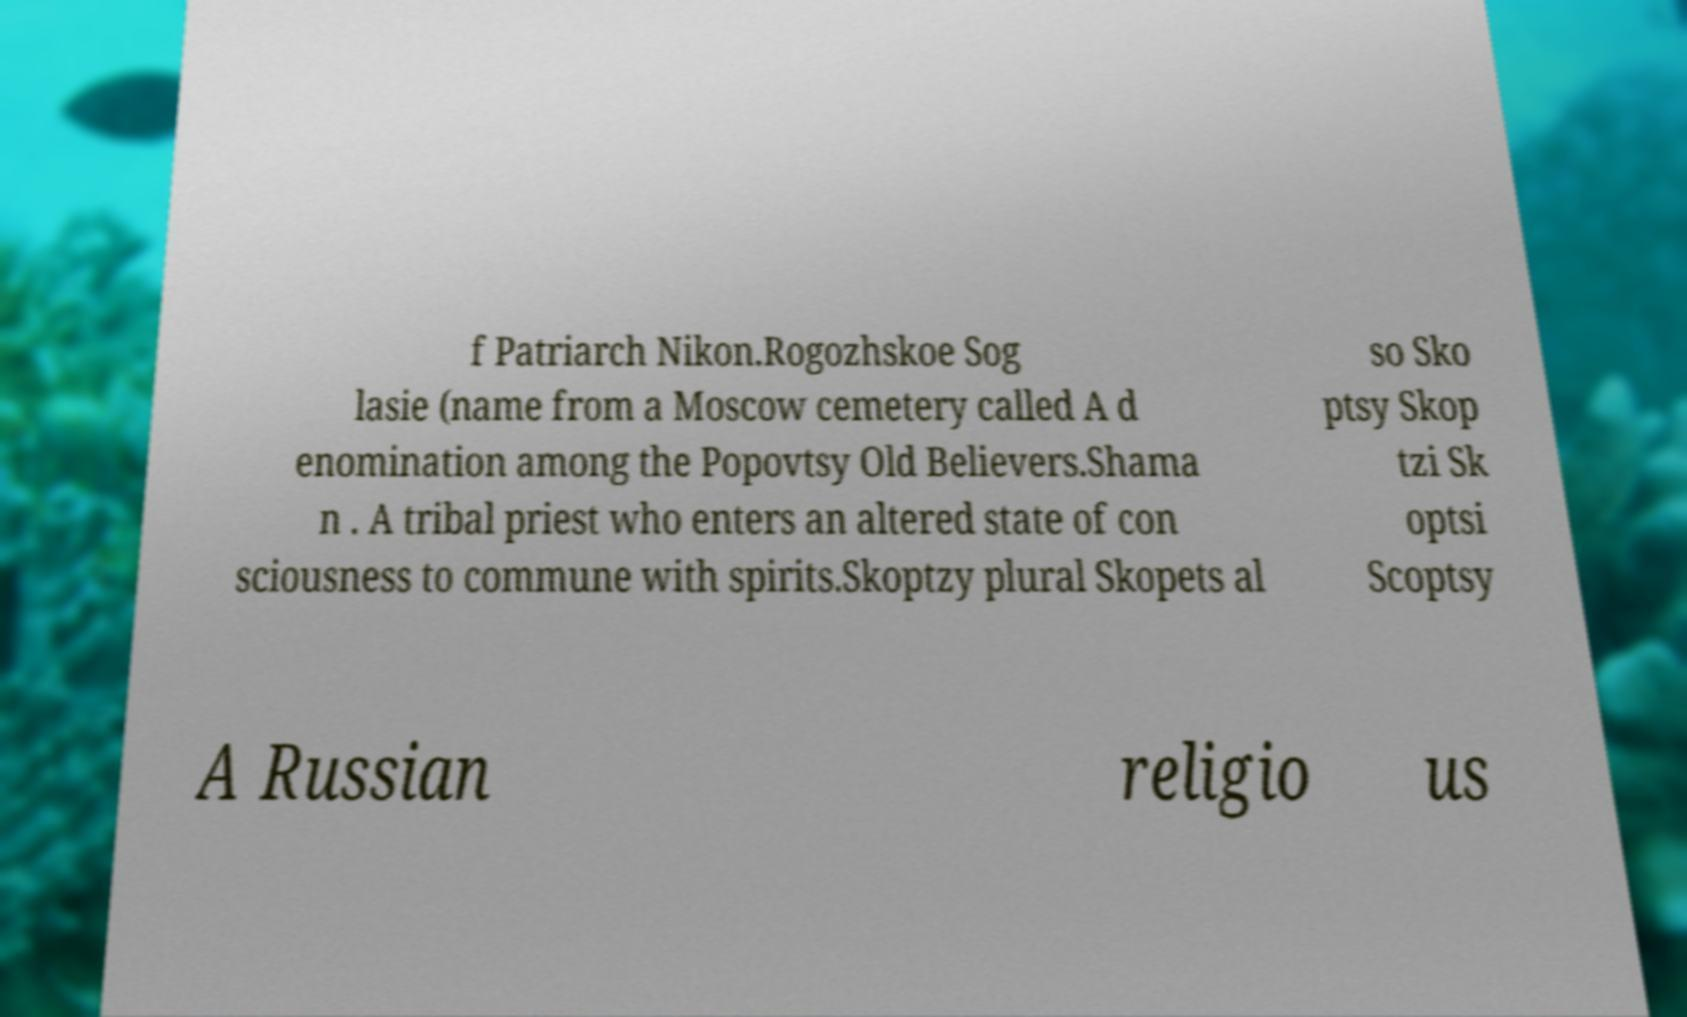Could you assist in decoding the text presented in this image and type it out clearly? f Patriarch Nikon.Rogozhskoe Sog lasie (name from a Moscow cemetery called A d enomination among the Popovtsy Old Believers.Shama n . A tribal priest who enters an altered state of con sciousness to commune with spirits.Skoptzy plural Skopets al so Sko ptsy Skop tzi Sk optsi Scoptsy A Russian religio us 